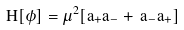Convert formula to latex. <formula><loc_0><loc_0><loc_500><loc_500>H [ \phi ] = \mu ^ { 2 } [ a _ { + } a _ { - } + \, a _ { - } a _ { + } ]</formula> 